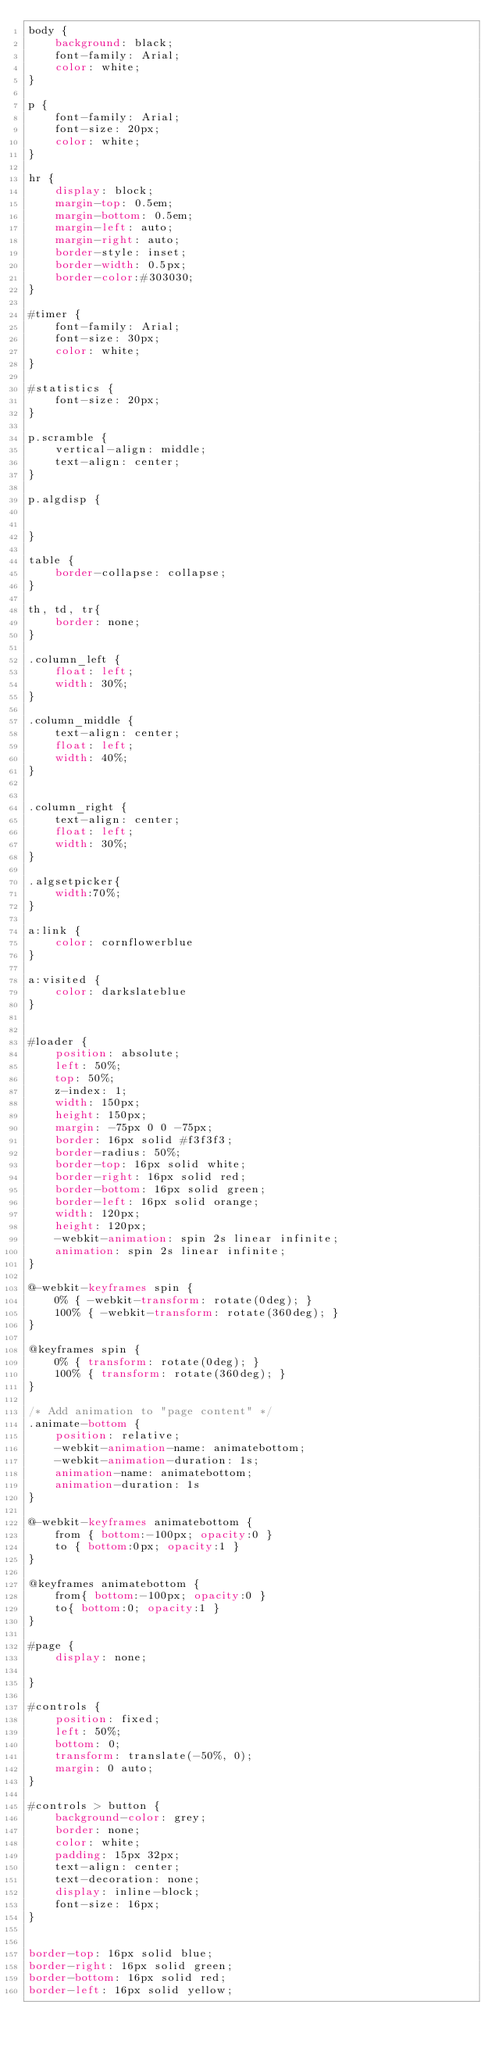<code> <loc_0><loc_0><loc_500><loc_500><_CSS_>body {
    background: black;
    font-family: Arial;
    color: white;
}

p {
    font-family: Arial;
    font-size: 20px;
    color: white;
}

hr { 
    display: block;
    margin-top: 0.5em;
    margin-bottom: 0.5em;
    margin-left: auto;
    margin-right: auto;
    border-style: inset;
    border-width: 0.5px;
    border-color:#303030;
}

#timer {
    font-family: Arial;
    font-size: 30px;
    color: white;
}

#statistics {
    font-size: 20px;
}

p.scramble {
    vertical-align: middle; 
    text-align: center;
}

p.algdisp {


}

table {
    border-collapse: collapse;
}

th, td, tr{
    border: none;
}

.column_left {
    float: left;
    width: 30%;
}

.column_middle {
    text-align: center;
    float: left;
    width: 40%;  
}


.column_right {
    text-align: center;
    float: left;
    width: 30%;
}

.algsetpicker{
    width:70%;
}

a:link {
    color: cornflowerblue
}

a:visited {
    color: darkslateblue
}


#loader {
    position: absolute;
    left: 50%;
    top: 50%;
    z-index: 1;
    width: 150px;
    height: 150px;
    margin: -75px 0 0 -75px;
    border: 16px solid #f3f3f3;
    border-radius: 50%;
    border-top: 16px solid white;
    border-right: 16px solid red;
    border-bottom: 16px solid green;
    border-left: 16px solid orange;
    width: 120px;
    height: 120px;
    -webkit-animation: spin 2s linear infinite;
    animation: spin 2s linear infinite;
}

@-webkit-keyframes spin {
    0% { -webkit-transform: rotate(0deg); }
    100% { -webkit-transform: rotate(360deg); }
}

@keyframes spin {
    0% { transform: rotate(0deg); }
    100% { transform: rotate(360deg); }
}

/* Add animation to "page content" */
.animate-bottom {
    position: relative;
    -webkit-animation-name: animatebottom;
    -webkit-animation-duration: 1s;
    animation-name: animatebottom;
    animation-duration: 1s
}

@-webkit-keyframes animatebottom {
    from { bottom:-100px; opacity:0 } 
    to { bottom:0px; opacity:1 }
}

@keyframes animatebottom { 
    from{ bottom:-100px; opacity:0 } 
    to{ bottom:0; opacity:1 }
}

#page {
    display: none;

}

#controls {   
    position: fixed;
    left: 50%;
    bottom: 0;
    transform: translate(-50%, 0);
    margin: 0 auto;
}

#controls > button {
    background-color: grey; 
    border: none;
    color: white;
    padding: 15px 32px;
    text-align: center;
    text-decoration: none;
    display: inline-block;
    font-size: 16px;
}


border-top: 16px solid blue;
border-right: 16px solid green;
border-bottom: 16px solid red;
border-left: 16px solid yellow;

</code> 